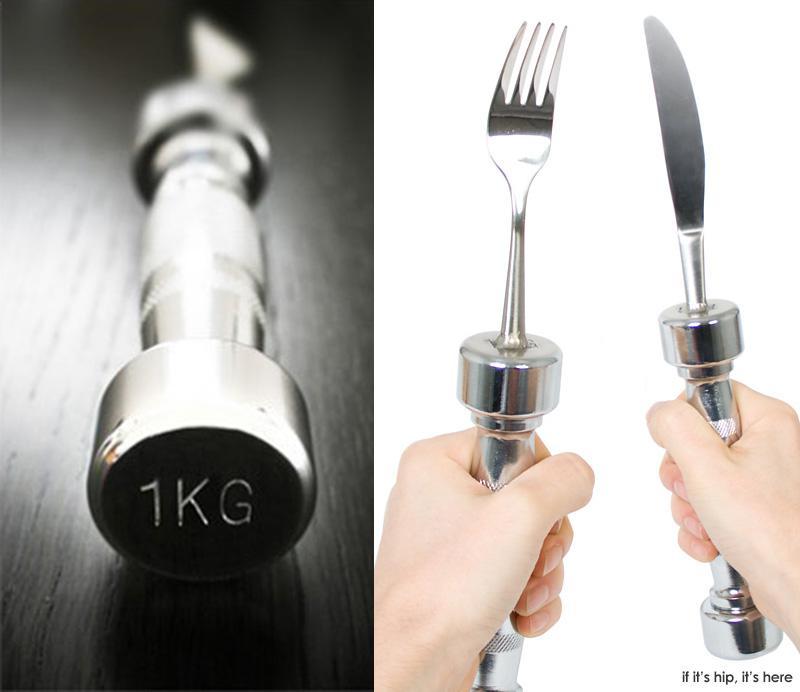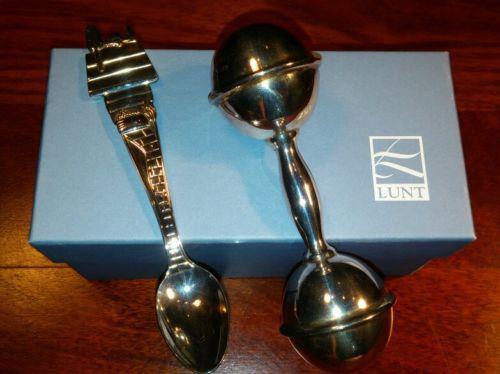The first image is the image on the left, the second image is the image on the right. For the images shown, is this caption "There is a knife, fork, and spoon in the image on the right." true? Answer yes or no. No. 